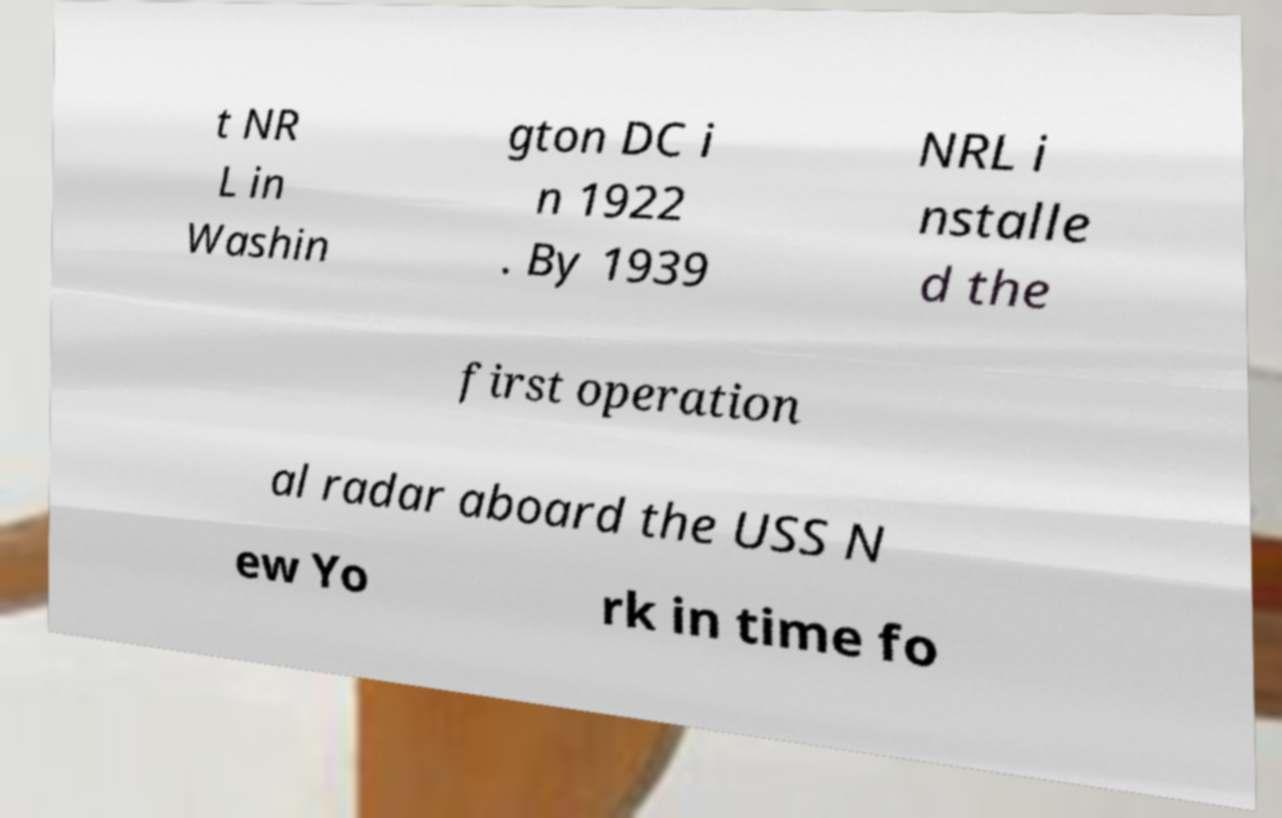Can you read and provide the text displayed in the image?This photo seems to have some interesting text. Can you extract and type it out for me? t NR L in Washin gton DC i n 1922 . By 1939 NRL i nstalle d the first operation al radar aboard the USS N ew Yo rk in time fo 